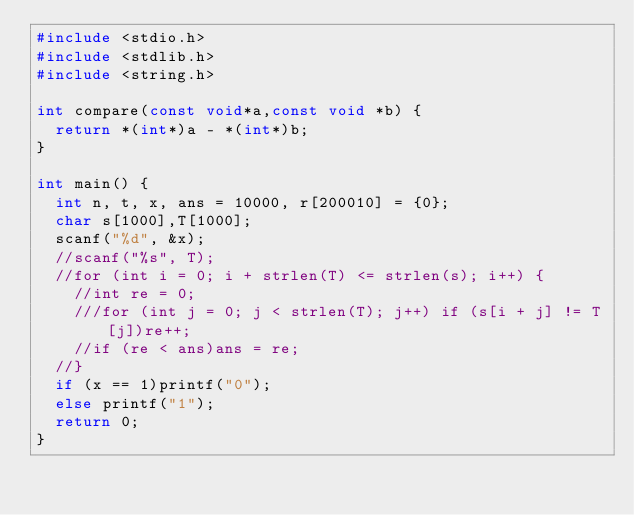Convert code to text. <code><loc_0><loc_0><loc_500><loc_500><_C_>#include <stdio.h>
#include <stdlib.h>
#include <string.h>

int compare(const void*a,const void *b) {
	return *(int*)a - *(int*)b;
}

int main() {
	int n, t, x, ans = 10000, r[200010] = {0};
	char s[1000],T[1000];
	scanf("%d", &x);
	//scanf("%s", T);
	//for (int i = 0; i + strlen(T) <= strlen(s); i++) {
		//int re = 0;
		///for (int j = 0; j < strlen(T); j++) if (s[i + j] != T[j])re++;
		//if (re < ans)ans = re;
	//}
	if (x == 1)printf("0");
	else printf("1");
	return 0;
}</code> 